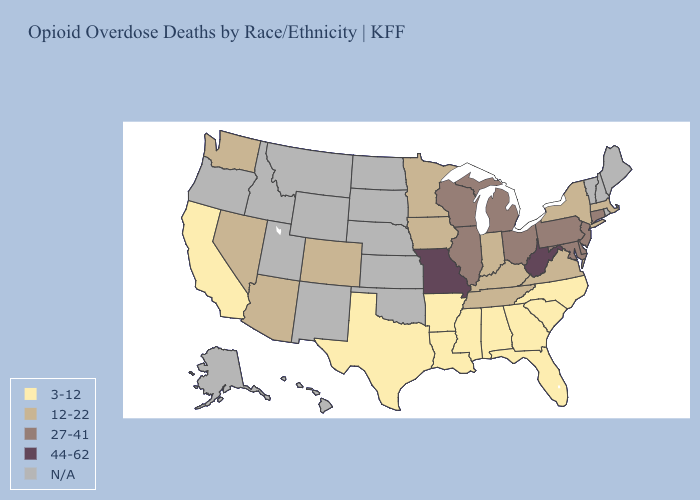Name the states that have a value in the range N/A?
Quick response, please. Alaska, Hawaii, Idaho, Kansas, Maine, Montana, Nebraska, New Hampshire, New Mexico, North Dakota, Oklahoma, Oregon, Rhode Island, South Dakota, Utah, Vermont, Wyoming. Among the states that border Georgia , which have the highest value?
Write a very short answer. Tennessee. Which states have the lowest value in the USA?
Keep it brief. Alabama, Arkansas, California, Florida, Georgia, Louisiana, Mississippi, North Carolina, South Carolina, Texas. Name the states that have a value in the range 44-62?
Be succinct. Missouri, West Virginia. Name the states that have a value in the range 27-41?
Answer briefly. Connecticut, Delaware, Illinois, Maryland, Michigan, New Jersey, Ohio, Pennsylvania, Wisconsin. What is the value of Pennsylvania?
Answer briefly. 27-41. Does Missouri have the highest value in the USA?
Quick response, please. Yes. Is the legend a continuous bar?
Give a very brief answer. No. Name the states that have a value in the range 44-62?
Keep it brief. Missouri, West Virginia. Does Connecticut have the highest value in the Northeast?
Quick response, please. Yes. What is the value of Pennsylvania?
Write a very short answer. 27-41. Name the states that have a value in the range 44-62?
Keep it brief. Missouri, West Virginia. What is the value of Kentucky?
Short answer required. 12-22. Which states have the lowest value in the USA?
Short answer required. Alabama, Arkansas, California, Florida, Georgia, Louisiana, Mississippi, North Carolina, South Carolina, Texas. 